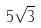<formula> <loc_0><loc_0><loc_500><loc_500>5 \sqrt { 3 }</formula> 